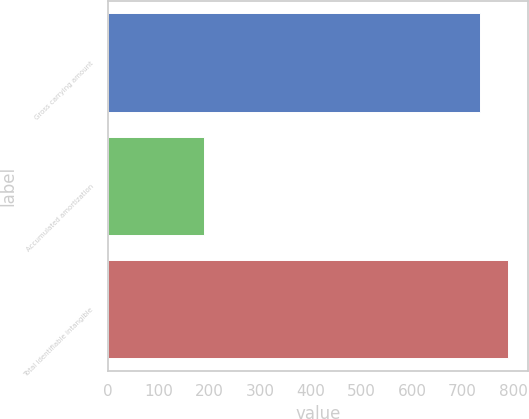Convert chart to OTSL. <chart><loc_0><loc_0><loc_500><loc_500><bar_chart><fcel>Gross carrying amount<fcel>Accumulated amortization<fcel>Total identifiable intangible<nl><fcel>733.9<fcel>190<fcel>789.28<nl></chart> 